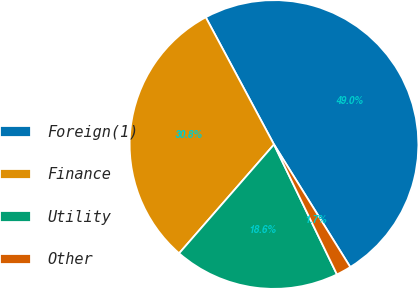Convert chart to OTSL. <chart><loc_0><loc_0><loc_500><loc_500><pie_chart><fcel>Foreign(1)<fcel>Finance<fcel>Utility<fcel>Other<nl><fcel>48.97%<fcel>30.75%<fcel>18.59%<fcel>1.68%<nl></chart> 